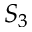<formula> <loc_0><loc_0><loc_500><loc_500>S _ { 3 }</formula> 